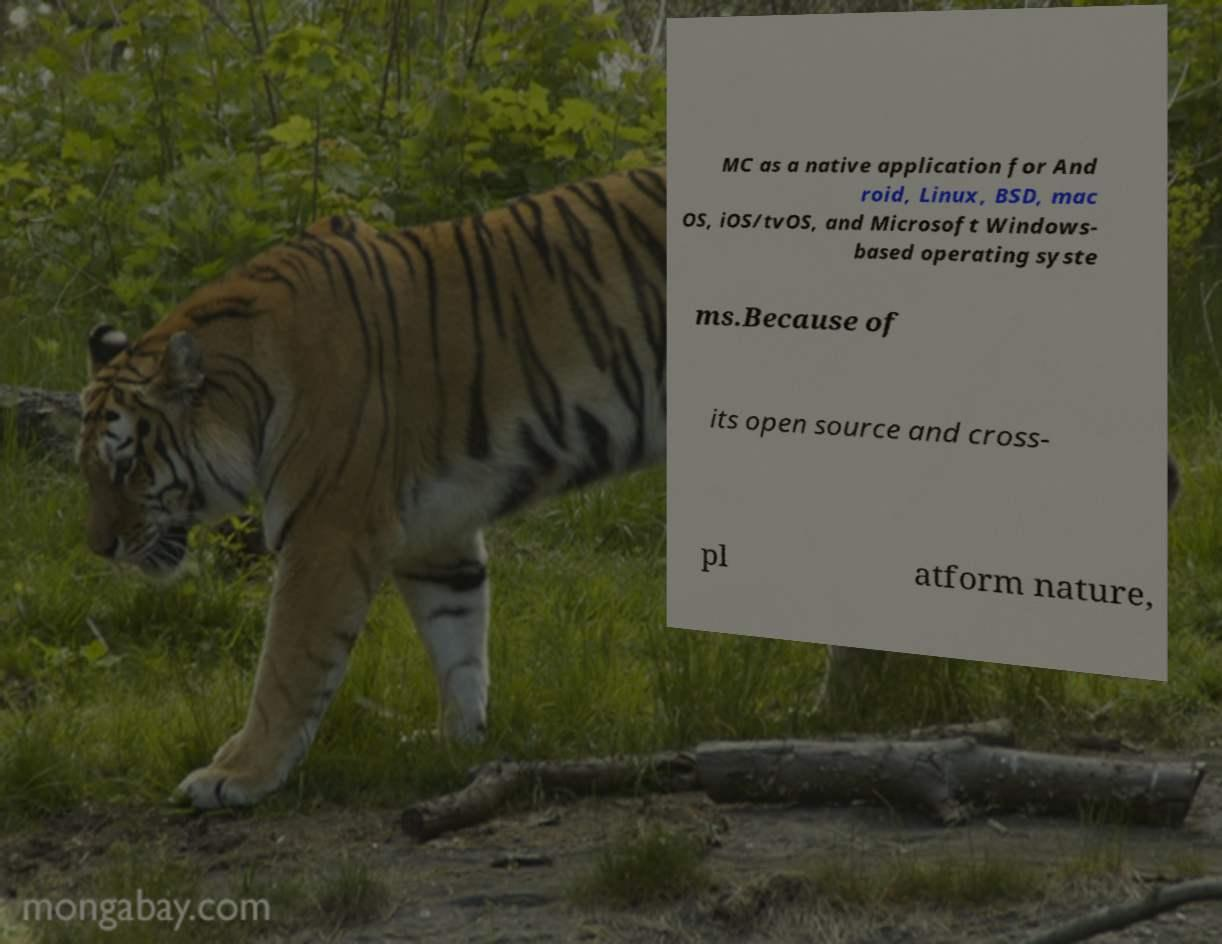I need the written content from this picture converted into text. Can you do that? MC as a native application for And roid, Linux, BSD, mac OS, iOS/tvOS, and Microsoft Windows- based operating syste ms.Because of its open source and cross- pl atform nature, 